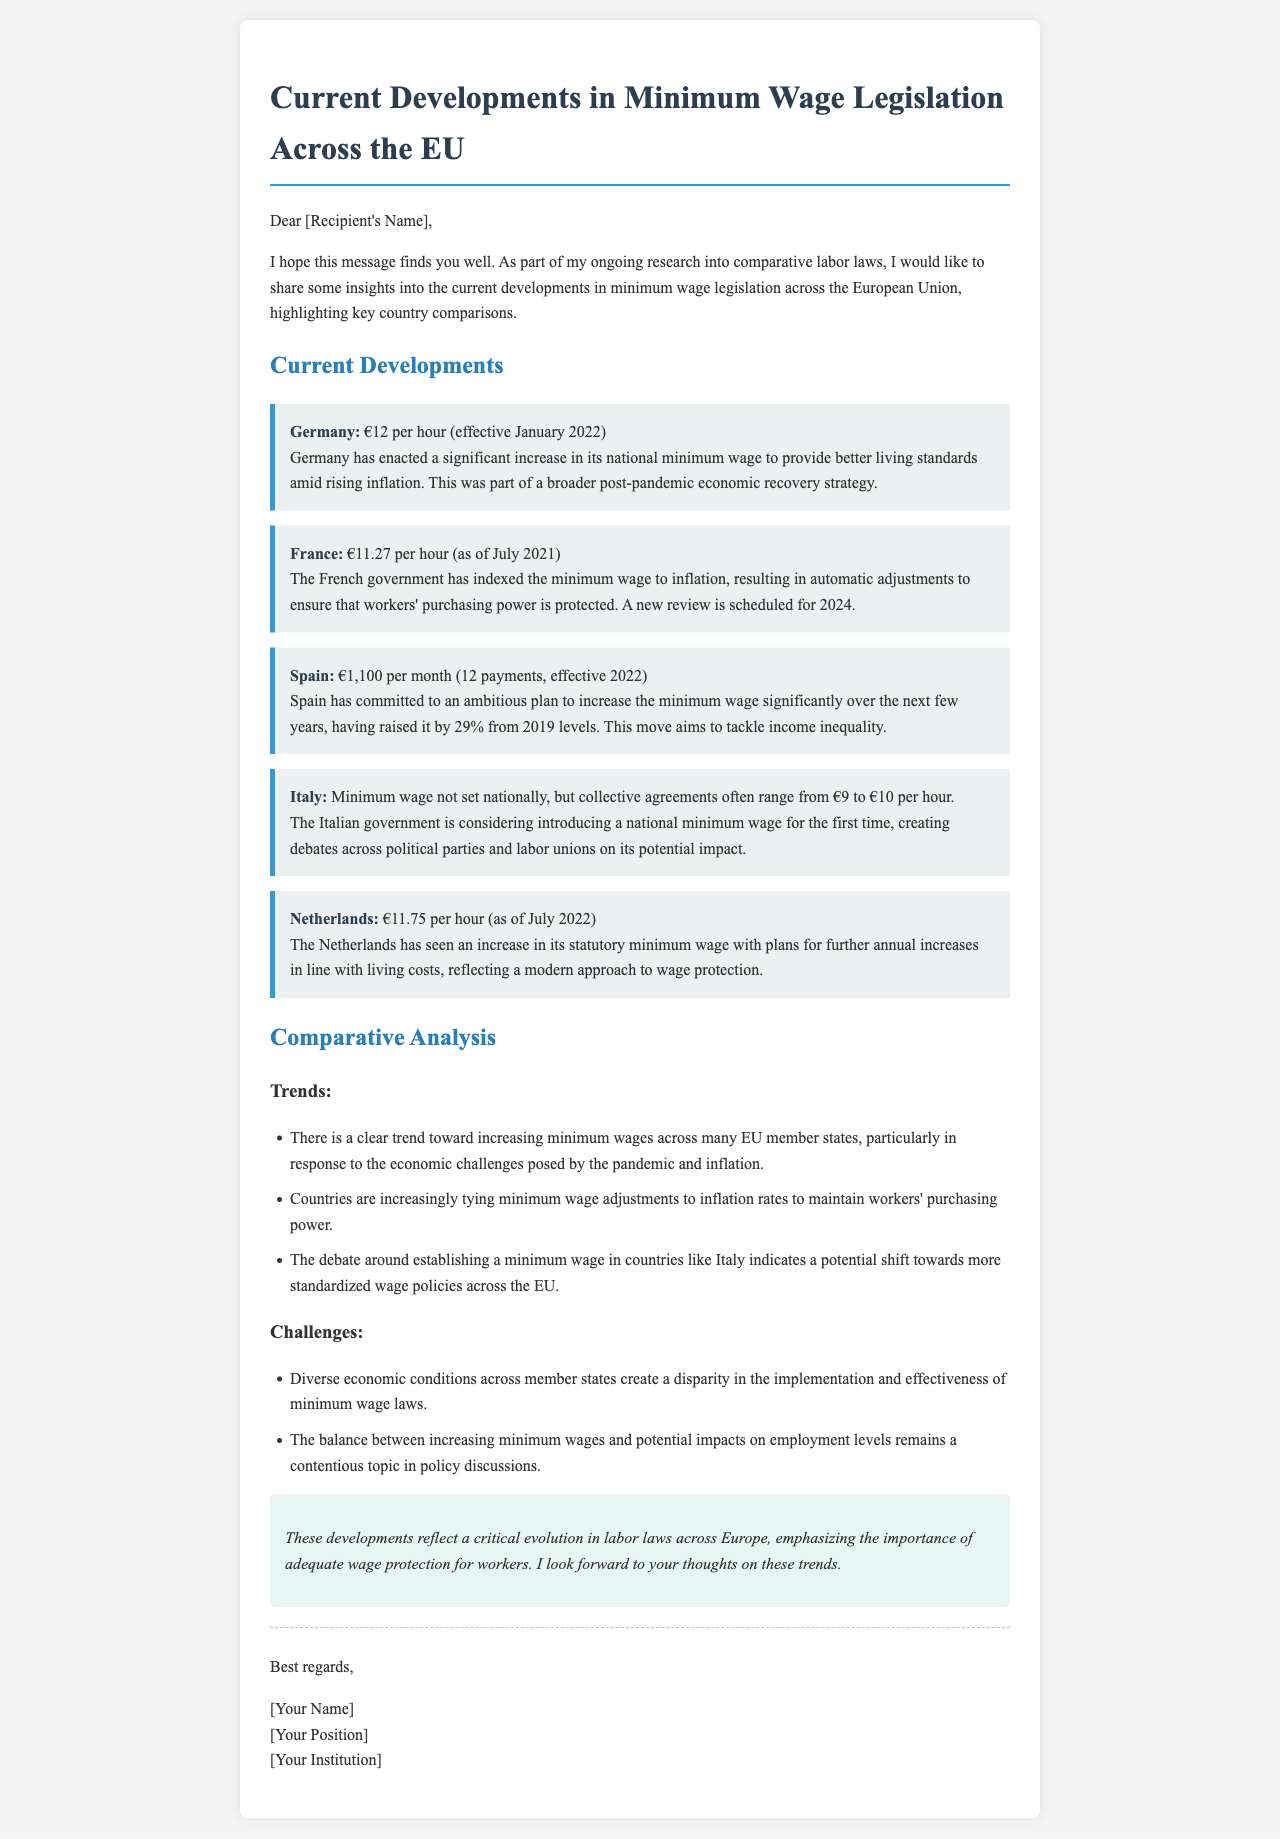What is the minimum wage in Germany? The document states that Germany has a minimum wage of €12 per hour, effective January 2022.
Answer: €12 per hour What is France's minimum wage as of July 2021? According to the email, France's minimum wage is €11.27 per hour as of July 2021.
Answer: €11.27 per hour How much did Spain raise its minimum wage from 2019 levels? The document notes that Spain raised its minimum wage by 29% from 2019 levels.
Answer: 29% What are the gender of the trends in minimum wage legislation? The document highlights trends such as increasing minimum wages and indexing minimum wage to inflation.
Answer: Increasing and indexing What is the proposed minimum wage in Italy? The document indicates that while no national minimum wage is currently set, collective agreements in Italy typically range from €9 to €10 per hour.
Answer: €9 to €10 per hour When is the next review of the minimum wage scheduled in France? The document mentions that a new review of the minimum wage in France is scheduled for 2024.
Answer: 2024 What challenges are associated with minimum wage laws in the EU? The challenges include diverse economic conditions and the impact on employment levels.
Answer: Diverse conditions and employment impacts What legislative approach is emphasized in the Netherlands? The email mentions that plans in the Netherlands include further annual increases in line with living costs.
Answer: Annual increases Who is the author of the email? The signature at the end of the email contains a placeholder for the author's name, but states '[Your Name]'.
Answer: [Your Name] 